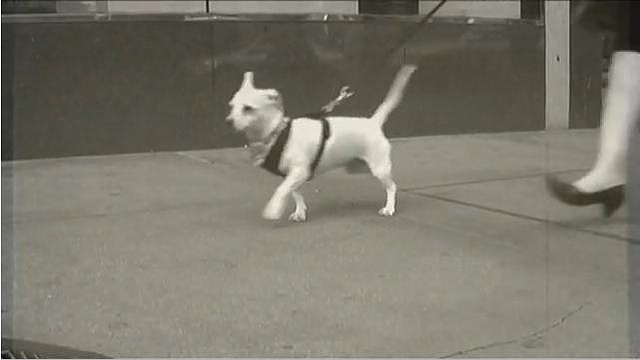Describe the objects in this image and their specific colors. I can see dog in white, lightgray, darkgray, and gray tones and people in white, darkgray, black, lightgray, and gray tones in this image. 